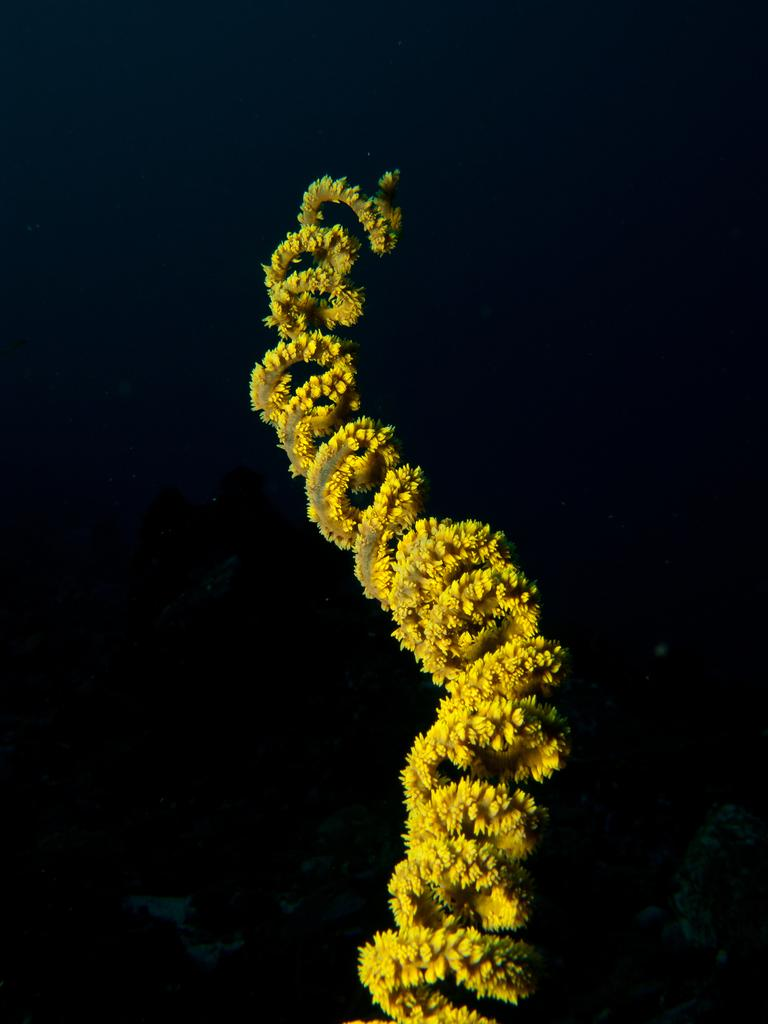What is the overall color scheme of the image? The background of the image is dark. What can be seen in the middle of the image? There is a garland in the middle of the image. What rule does the maid follow when cleaning the nose in the image? There is no maid or nose present in the image, so it is not possible to answer that question. 